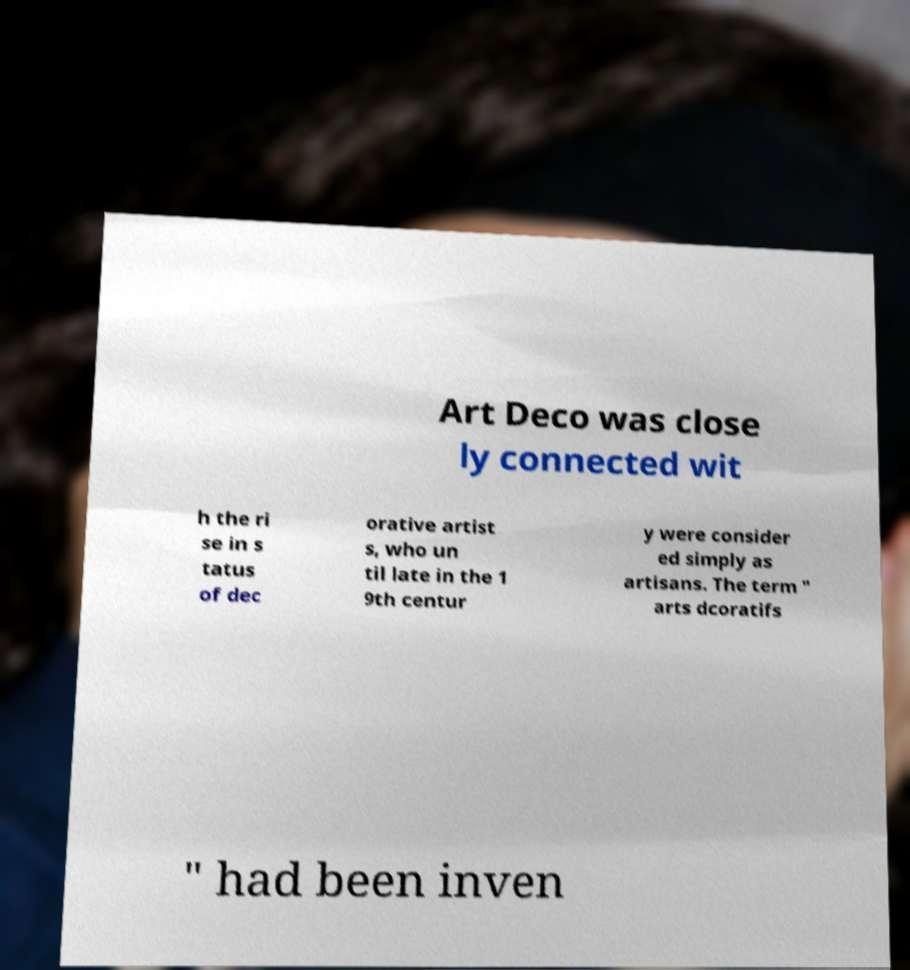Can you read and provide the text displayed in the image?This photo seems to have some interesting text. Can you extract and type it out for me? Art Deco was close ly connected wit h the ri se in s tatus of dec orative artist s, who un til late in the 1 9th centur y were consider ed simply as artisans. The term " arts dcoratifs " had been inven 